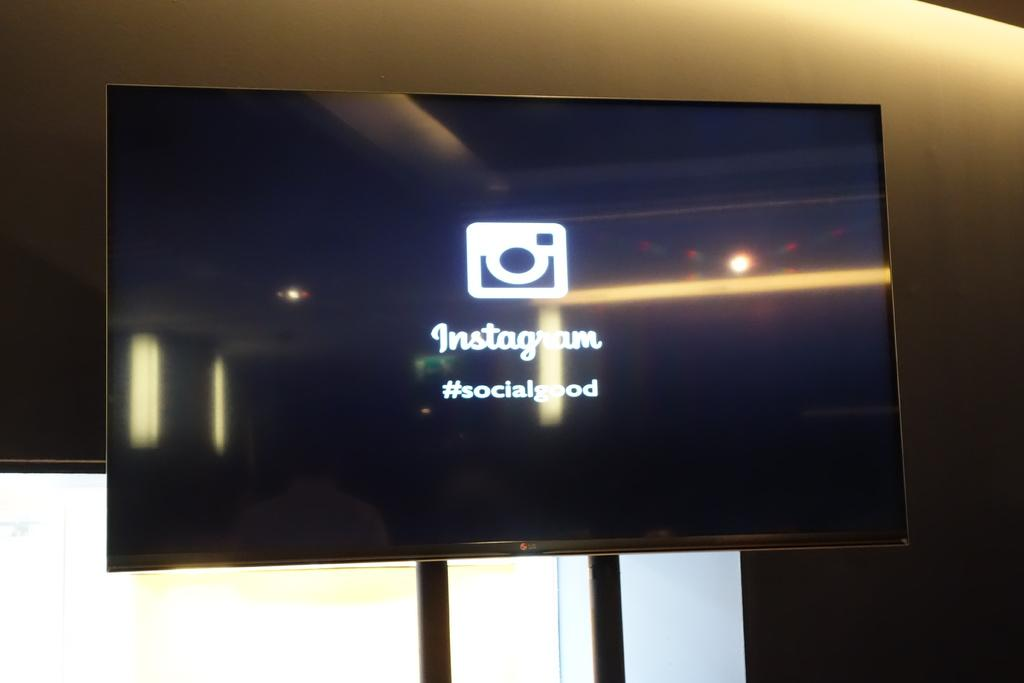<image>
Summarize the visual content of the image. A LG television has the Instagram logo and name on its screen. 